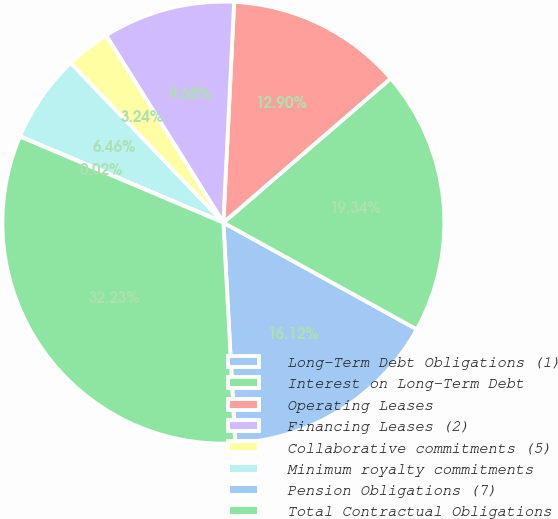Convert chart. <chart><loc_0><loc_0><loc_500><loc_500><pie_chart><fcel>Long-Term Debt Obligations (1)<fcel>Interest on Long-Term Debt<fcel>Operating Leases<fcel>Financing Leases (2)<fcel>Collaborative commitments (5)<fcel>Minimum royalty commitments<fcel>Pension Obligations (7)<fcel>Total Contractual Obligations<nl><fcel>16.12%<fcel>19.34%<fcel>12.9%<fcel>9.68%<fcel>3.24%<fcel>6.46%<fcel>0.02%<fcel>32.22%<nl></chart> 